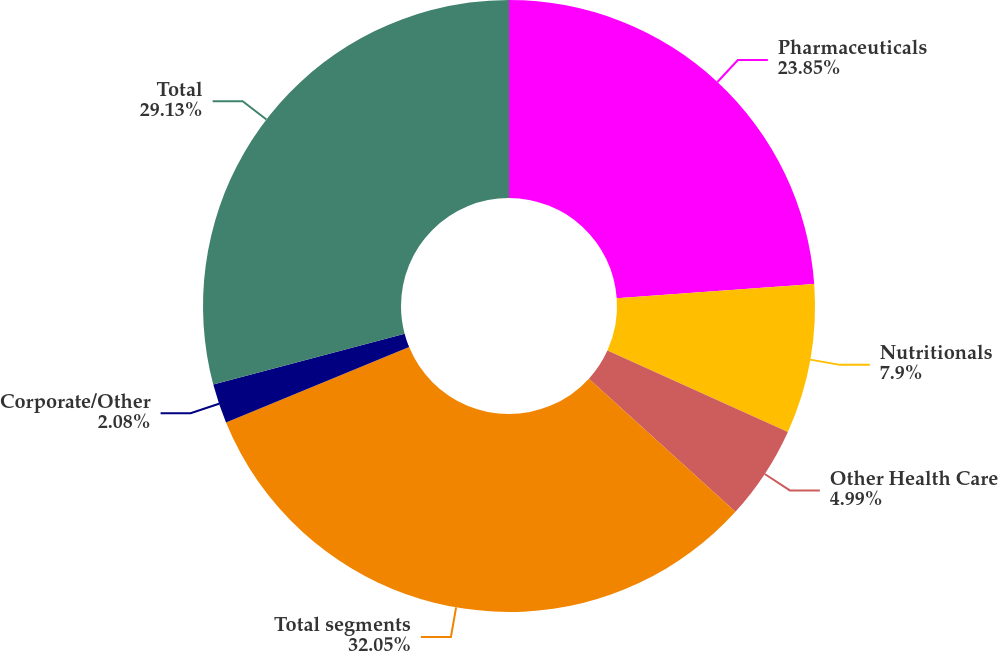Convert chart to OTSL. <chart><loc_0><loc_0><loc_500><loc_500><pie_chart><fcel>Pharmaceuticals<fcel>Nutritionals<fcel>Other Health Care<fcel>Total segments<fcel>Corporate/Other<fcel>Total<nl><fcel>23.85%<fcel>7.9%<fcel>4.99%<fcel>32.04%<fcel>2.08%<fcel>29.13%<nl></chart> 